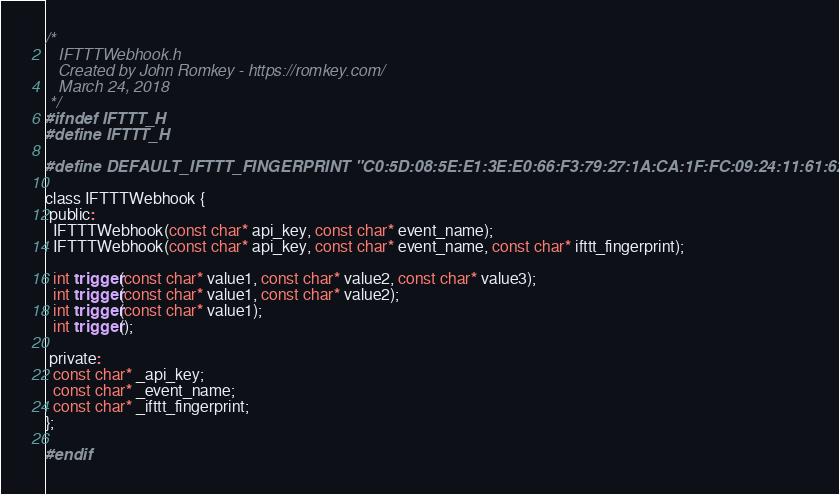Convert code to text. <code><loc_0><loc_0><loc_500><loc_500><_C_>/* 
   IFTTTWebhook.h
   Created by John Romkey - https://romkey.com/
   March 24, 2018
 */
#ifndef IFTTT_H
#define IFTTT_H

#define DEFAULT_IFTTT_FINGERPRINT "C0:5D:08:5E:E1:3E:E0:66:F3:79:27:1A:CA:1F:FC:09:24:11:61:62"

class IFTTTWebhook {
 public:
  IFTTTWebhook(const char* api_key, const char* event_name);
  IFTTTWebhook(const char* api_key, const char* event_name, const char* ifttt_fingerprint);
  
  int trigger(const char* value1, const char* value2, const char* value3);
  int trigger(const char* value1, const char* value2);
  int trigger(const char* value1);
  int trigger();
  
 private:
  const char* _api_key;
  const char* _event_name;
  const char* _ifttt_fingerprint;
};

#endif

</code> 